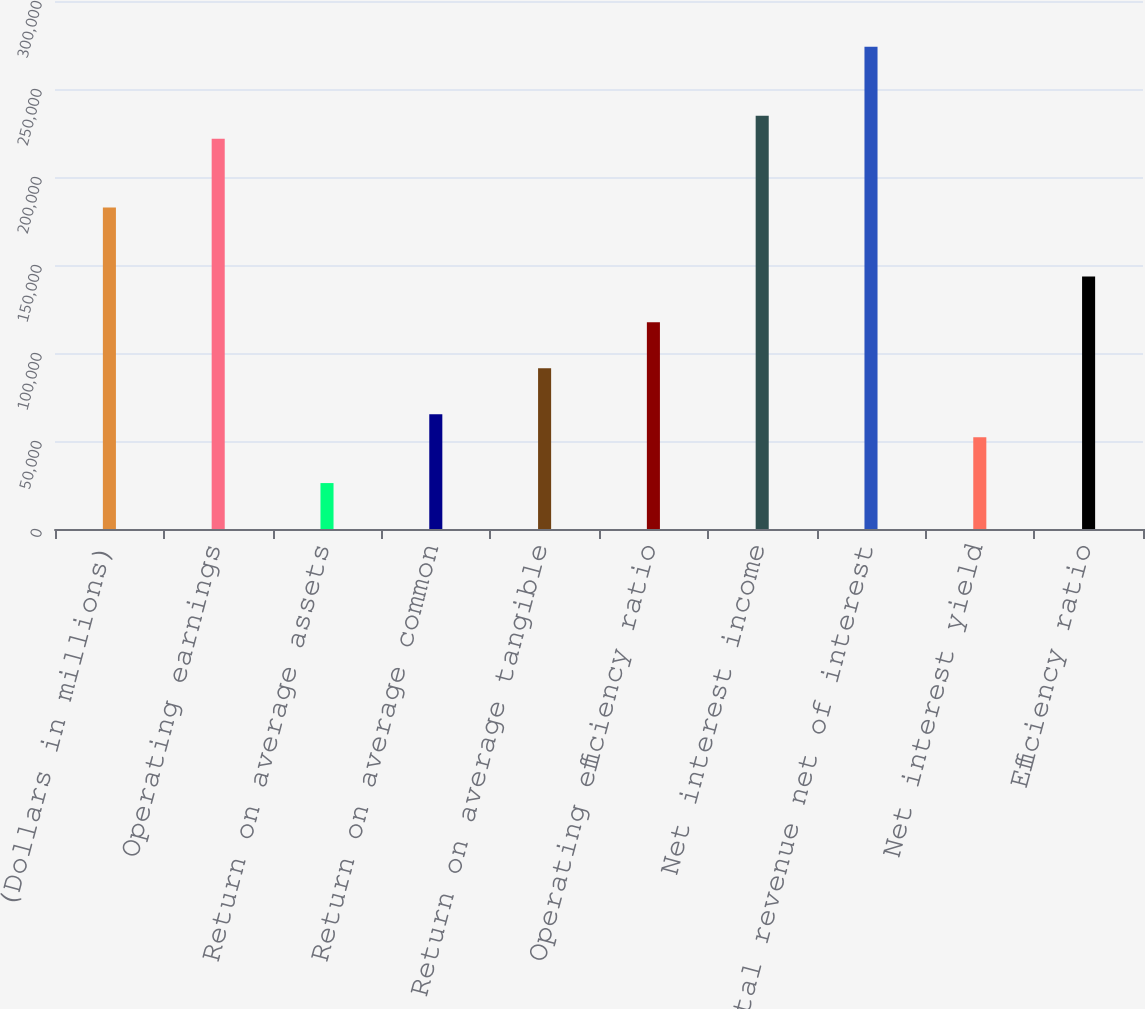<chart> <loc_0><loc_0><loc_500><loc_500><bar_chart><fcel>(Dollars in millions)<fcel>Operating earnings<fcel>Return on average assets<fcel>Return on average common<fcel>Return on average tangible<fcel>Operating efficiency ratio<fcel>Net interest income<fcel>Total revenue net of interest<fcel>Net interest yield<fcel>Efficiency ratio<nl><fcel>182648<fcel>221787<fcel>26092.6<fcel>65231.5<fcel>91324.1<fcel>117417<fcel>234833<fcel>273972<fcel>52185.2<fcel>143509<nl></chart> 